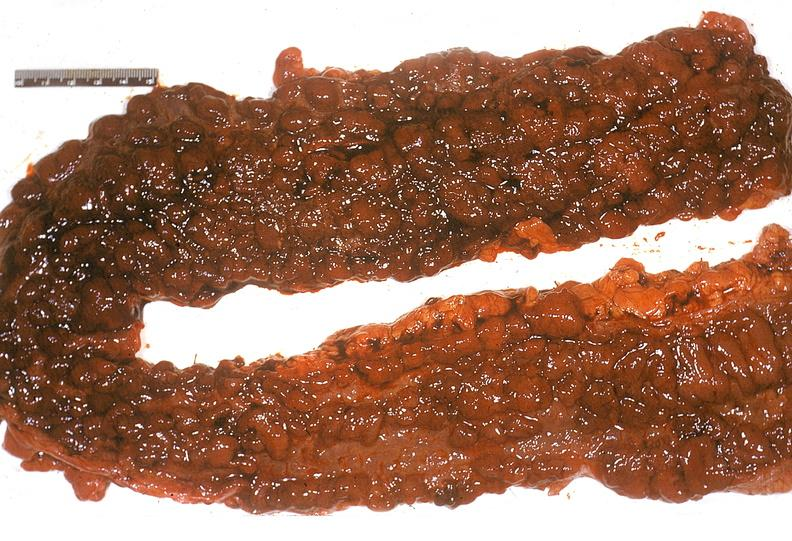what is present?
Answer the question using a single word or phrase. Gastrointestinal 